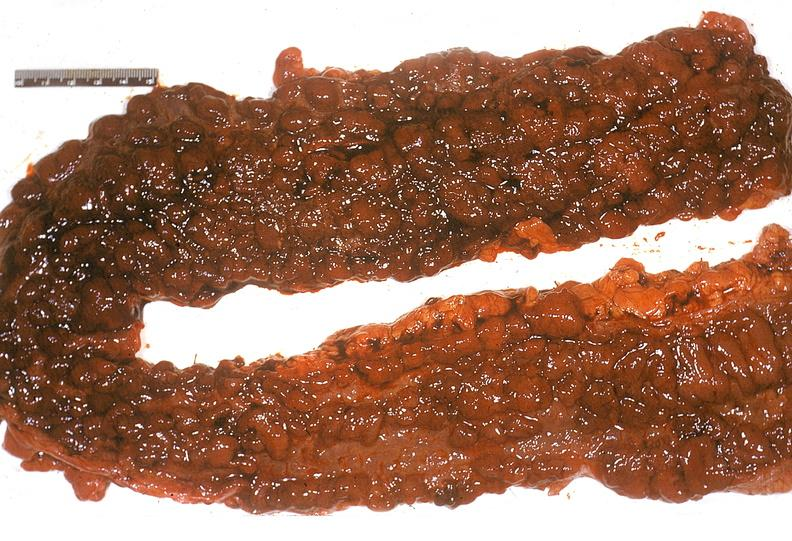what is present?
Answer the question using a single word or phrase. Gastrointestinal 